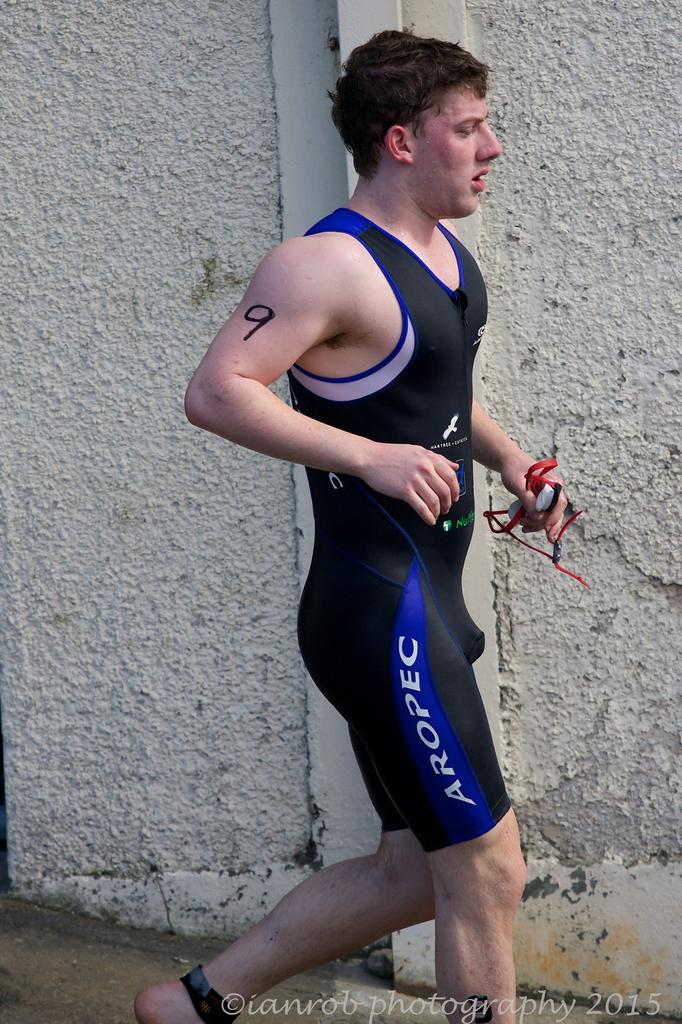What is the person in the image doing? The person is running in the image. What is the person wearing? The person is wearing a black and blue dress. What is the person holding? The person is holding something, but we cannot determine what it is from the image. What can be seen in the background of the image? There is a white wall visible in the background of the image. What type of wilderness can be seen in the background of the image? There is no wilderness visible in the background of the image; it features a white wall. How many things can be seen on the person's head in the image? There is no indication of any things on the person's head in the image. 